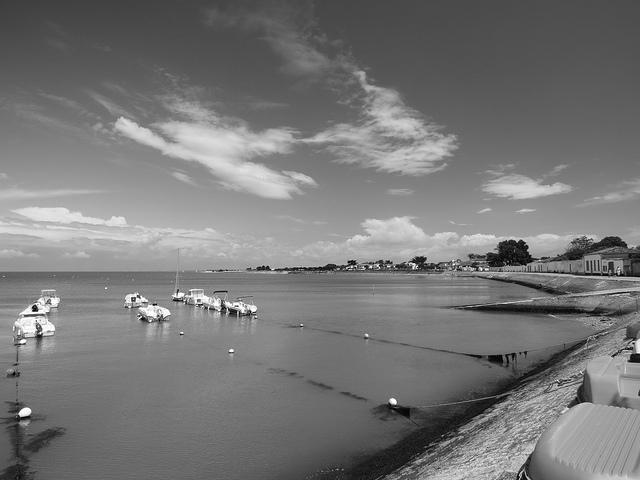What vehicles are located in the water?
Pick the right solution, then justify: 'Answer: answer
Rationale: rationale.'
Options: Yacht, boat, canoe, jet ski. Answer: boat.
Rationale: These are pleasure vehicles to enjoy the water 